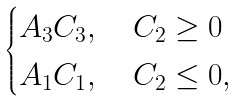<formula> <loc_0><loc_0><loc_500><loc_500>\begin{cases} A _ { 3 } C _ { 3 } , \quad C _ { 2 } \geq 0 \\ A _ { 1 } C _ { 1 } , \quad C _ { 2 } \leq 0 , \end{cases}</formula> 